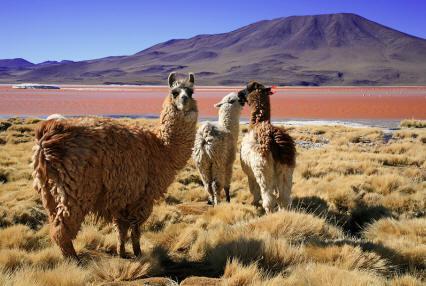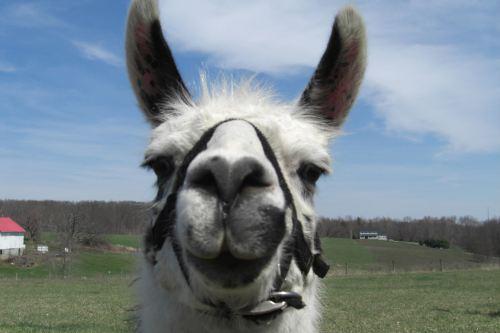The first image is the image on the left, the second image is the image on the right. Evaluate the accuracy of this statement regarding the images: "The left image contains exactly three shaggy llamas standing in front of a brown hill, with at least one llama looking directly at the camera.". Is it true? Answer yes or no. Yes. The first image is the image on the left, the second image is the image on the right. Considering the images on both sides, is "There are three llamas in the left image." valid? Answer yes or no. Yes. 